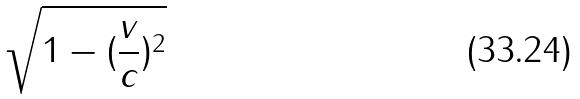<formula> <loc_0><loc_0><loc_500><loc_500>\sqrt { 1 - ( \frac { v } { c } ) ^ { 2 } }</formula> 